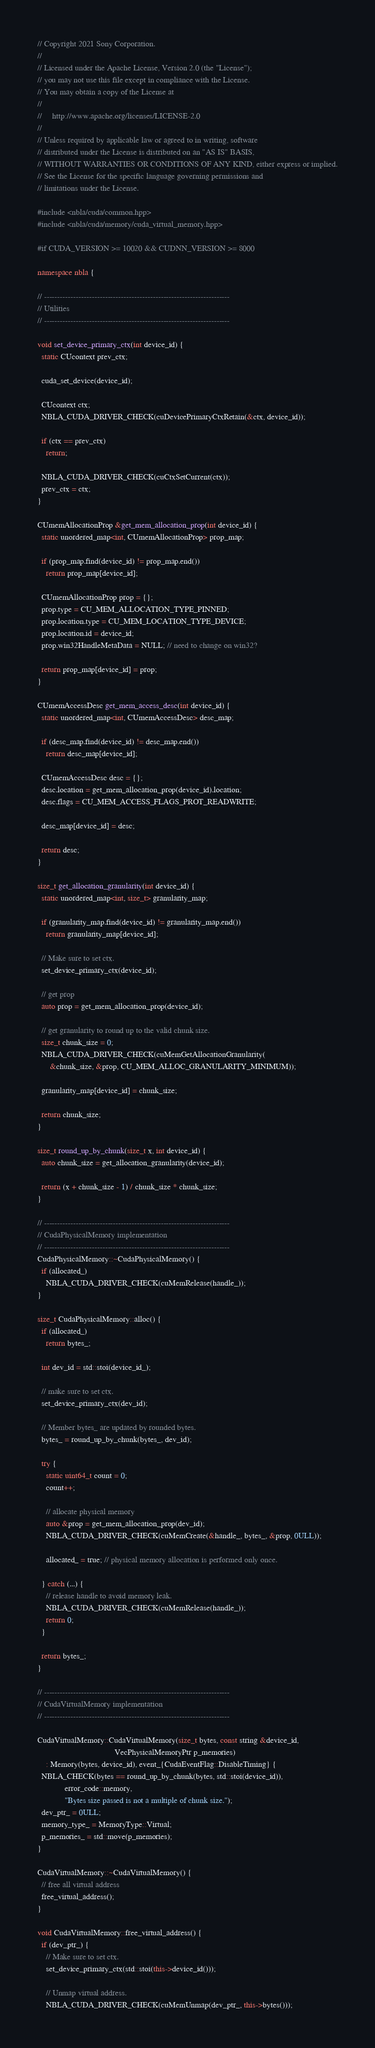Convert code to text. <code><loc_0><loc_0><loc_500><loc_500><_C++_>// Copyright 2021 Sony Corporation.
//
// Licensed under the Apache License, Version 2.0 (the "License");
// you may not use this file except in compliance with the License.
// You may obtain a copy of the License at
//
//     http://www.apache.org/licenses/LICENSE-2.0
//
// Unless required by applicable law or agreed to in writing, software
// distributed under the License is distributed on an "AS IS" BASIS,
// WITHOUT WARRANTIES OR CONDITIONS OF ANY KIND, either express or implied.
// See the License for the specific language governing permissions and
// limitations under the License.

#include <nbla/cuda/common.hpp>
#include <nbla/cuda/memory/cuda_virtual_memory.hpp>

#if CUDA_VERSION >= 10020 && CUDNN_VERSION >= 8000

namespace nbla {

// ----------------------------------------------------------------------
// Utilities
// ----------------------------------------------------------------------

void set_device_primary_ctx(int device_id) {
  static CUcontext prev_ctx;

  cuda_set_device(device_id);

  CUcontext ctx;
  NBLA_CUDA_DRIVER_CHECK(cuDevicePrimaryCtxRetain(&ctx, device_id));

  if (ctx == prev_ctx)
    return;

  NBLA_CUDA_DRIVER_CHECK(cuCtxSetCurrent(ctx));
  prev_ctx = ctx;
}

CUmemAllocationProp &get_mem_allocation_prop(int device_id) {
  static unordered_map<int, CUmemAllocationProp> prop_map;

  if (prop_map.find(device_id) != prop_map.end())
    return prop_map[device_id];

  CUmemAllocationProp prop = {};
  prop.type = CU_MEM_ALLOCATION_TYPE_PINNED;
  prop.location.type = CU_MEM_LOCATION_TYPE_DEVICE;
  prop.location.id = device_id;
  prop.win32HandleMetaData = NULL; // need to change on win32?

  return prop_map[device_id] = prop;
}

CUmemAccessDesc get_mem_access_desc(int device_id) {
  static unordered_map<int, CUmemAccessDesc> desc_map;

  if (desc_map.find(device_id) != desc_map.end())
    return desc_map[device_id];

  CUmemAccessDesc desc = {};
  desc.location = get_mem_allocation_prop(device_id).location;
  desc.flags = CU_MEM_ACCESS_FLAGS_PROT_READWRITE;

  desc_map[device_id] = desc;

  return desc;
}

size_t get_allocation_granularity(int device_id) {
  static unordered_map<int, size_t> granularity_map;

  if (granularity_map.find(device_id) != granularity_map.end())
    return granularity_map[device_id];

  // Make sure to set ctx.
  set_device_primary_ctx(device_id);

  // get prop
  auto prop = get_mem_allocation_prop(device_id);

  // get granularity to round up to the valid chunk size.
  size_t chunk_size = 0;
  NBLA_CUDA_DRIVER_CHECK(cuMemGetAllocationGranularity(
      &chunk_size, &prop, CU_MEM_ALLOC_GRANULARITY_MINIMUM));

  granularity_map[device_id] = chunk_size;

  return chunk_size;
}

size_t round_up_by_chunk(size_t x, int device_id) {
  auto chunk_size = get_allocation_granularity(device_id);

  return (x + chunk_size - 1) / chunk_size * chunk_size;
}

// ----------------------------------------------------------------------
// CudaPhysicalMemory implementation
// ----------------------------------------------------------------------
CudaPhysicalMemory::~CudaPhysicalMemory() {
  if (allocated_)
    NBLA_CUDA_DRIVER_CHECK(cuMemRelease(handle_));
}

size_t CudaPhysicalMemory::alloc() {
  if (allocated_)
    return bytes_;

  int dev_id = std::stoi(device_id_);

  // make sure to set ctx.
  set_device_primary_ctx(dev_id);

  // Member bytes_ are updated by rounded bytes.
  bytes_ = round_up_by_chunk(bytes_, dev_id);

  try {
    static uint64_t count = 0;
    count++;

    // allocate physical memory
    auto &prop = get_mem_allocation_prop(dev_id);
    NBLA_CUDA_DRIVER_CHECK(cuMemCreate(&handle_, bytes_, &prop, 0ULL));

    allocated_ = true; // physical memory allocation is performed only once.

  } catch (...) {
    // release handle to avoid memory leak.
    NBLA_CUDA_DRIVER_CHECK(cuMemRelease(handle_));
    return 0;
  }

  return bytes_;
}

// ----------------------------------------------------------------------
// CudaVirtualMemory implementation
// ----------------------------------------------------------------------

CudaVirtualMemory::CudaVirtualMemory(size_t bytes, const string &device_id,
                                     VecPhysicalMemoryPtr p_memories)
    : Memory(bytes, device_id), event_{CudaEventFlag::DisableTiming} {
  NBLA_CHECK(bytes == round_up_by_chunk(bytes, std::stoi(device_id)),
             error_code::memory,
             "Bytes size passed is not a multiple of chunk size.");
  dev_ptr_ = 0ULL;
  memory_type_ = MemoryType::Virtual;
  p_memories_ = std::move(p_memories);
}

CudaVirtualMemory::~CudaVirtualMemory() {
  // free all virtual address
  free_virtual_address();
}

void CudaVirtualMemory::free_virtual_address() {
  if (dev_ptr_) {
    // Make sure to set ctx.
    set_device_primary_ctx(std::stoi(this->device_id()));

    // Unmap virtual address.
    NBLA_CUDA_DRIVER_CHECK(cuMemUnmap(dev_ptr_, this->bytes()));
</code> 